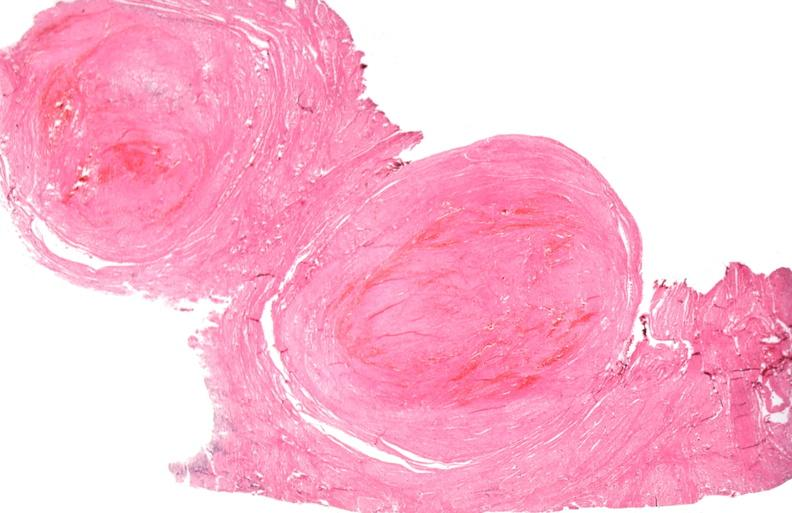s female reproductive present?
Answer the question using a single word or phrase. Yes 